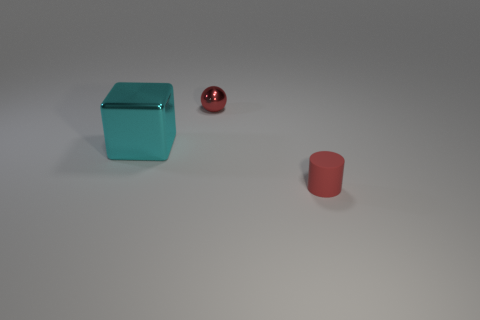Add 2 blue metallic balls. How many objects exist? 5 Subtract all cubes. How many objects are left? 2 Subtract all tiny brown rubber objects. Subtract all large cyan metal blocks. How many objects are left? 2 Add 1 shiny blocks. How many shiny blocks are left? 2 Add 1 tiny spheres. How many tiny spheres exist? 2 Subtract 0 gray cylinders. How many objects are left? 3 Subtract all brown blocks. Subtract all purple cylinders. How many blocks are left? 1 